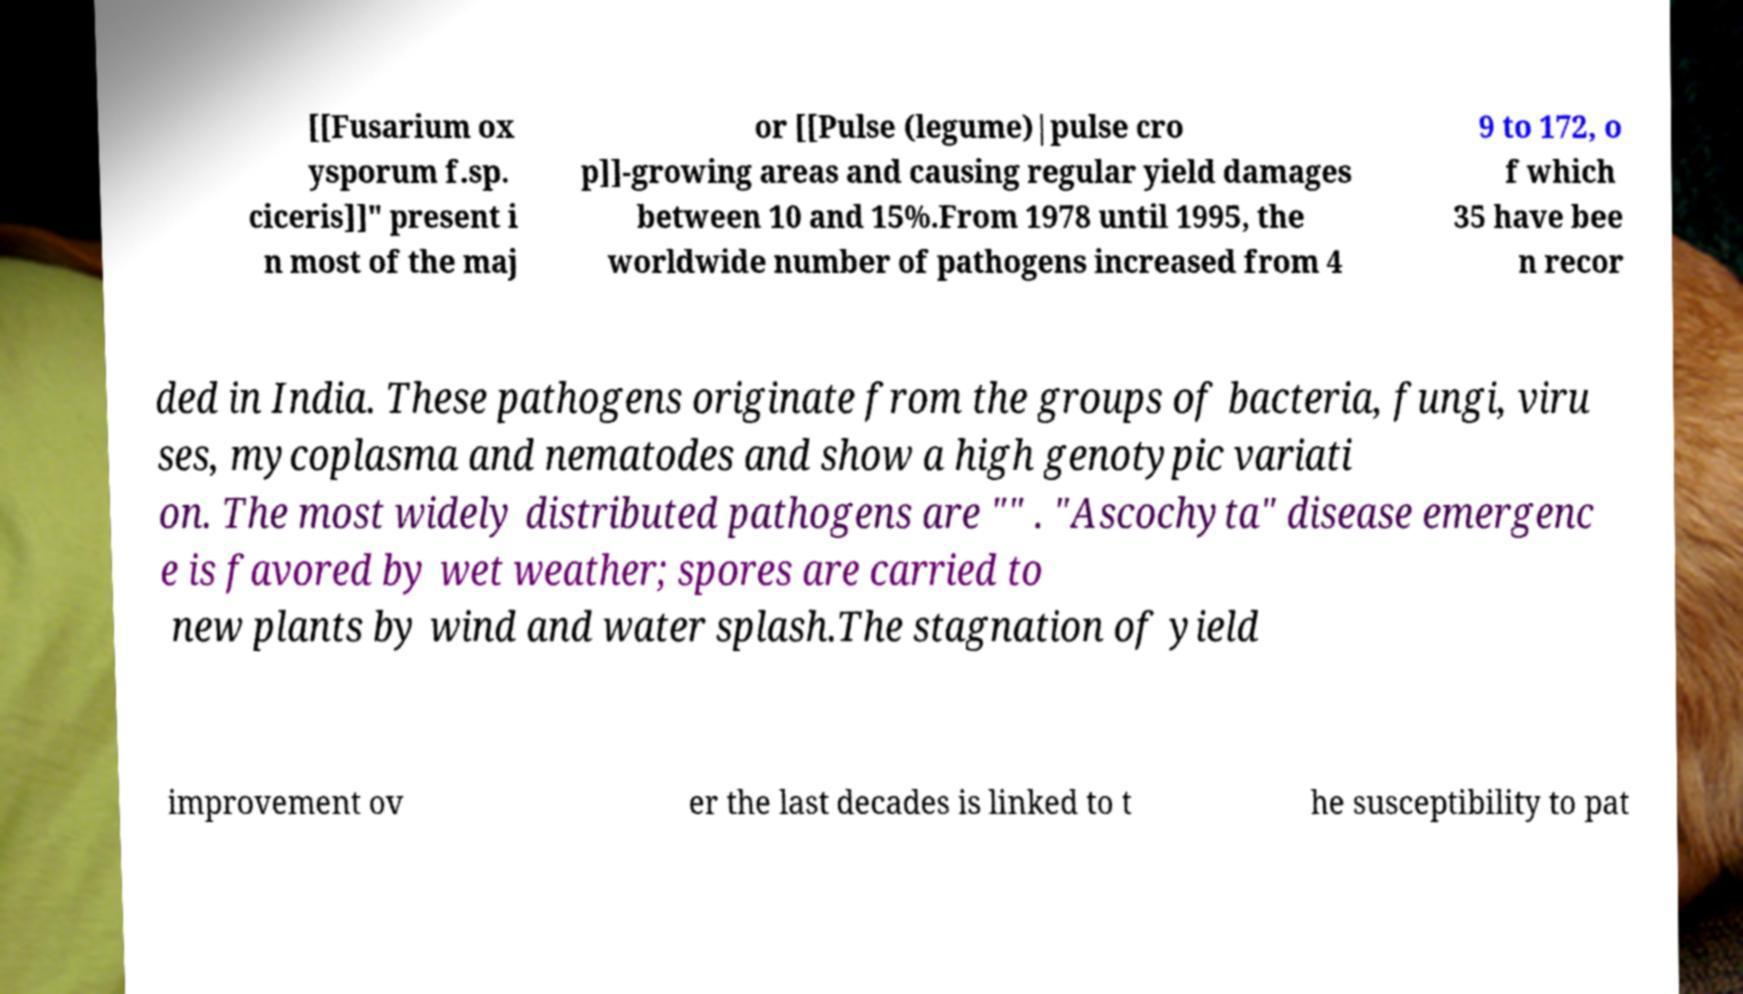Could you assist in decoding the text presented in this image and type it out clearly? [[Fusarium ox ysporum f.sp. ciceris]]" present i n most of the maj or [[Pulse (legume)|pulse cro p]]-growing areas and causing regular yield damages between 10 and 15%.From 1978 until 1995, the worldwide number of pathogens increased from 4 9 to 172, o f which 35 have bee n recor ded in India. These pathogens originate from the groups of bacteria, fungi, viru ses, mycoplasma and nematodes and show a high genotypic variati on. The most widely distributed pathogens are "" . "Ascochyta" disease emergenc e is favored by wet weather; spores are carried to new plants by wind and water splash.The stagnation of yield improvement ov er the last decades is linked to t he susceptibility to pat 